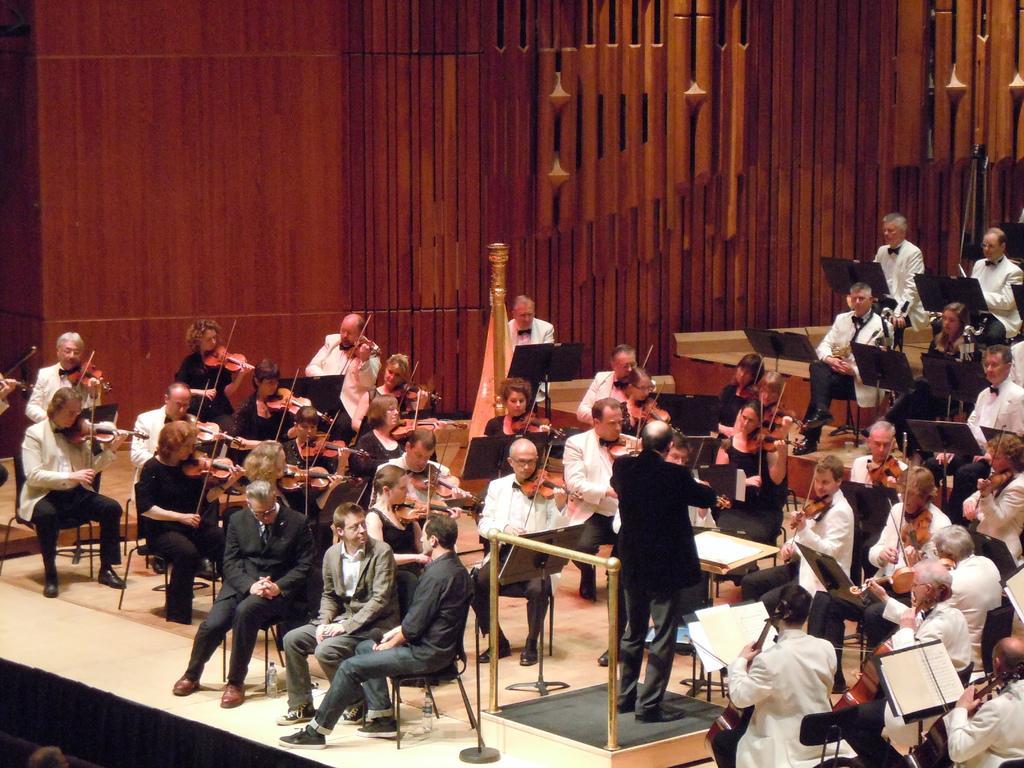Please provide a concise description of this image. In this image I see number of people who are sitting on chairs and this man is standing and I see that most of them are wearing same dress and most of them are holding musical instruments in their hands and I see the brown color wall in the background. 